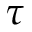<formula> <loc_0><loc_0><loc_500><loc_500>\tau</formula> 